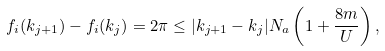Convert formula to latex. <formula><loc_0><loc_0><loc_500><loc_500>f _ { i } ( k _ { j + 1 } ) - f _ { i } ( k _ { j } ) = 2 \pi \leq | k _ { j + 1 } - k _ { j } | N _ { a } \left ( 1 + \frac { 8 m } { U } \right ) ,</formula> 